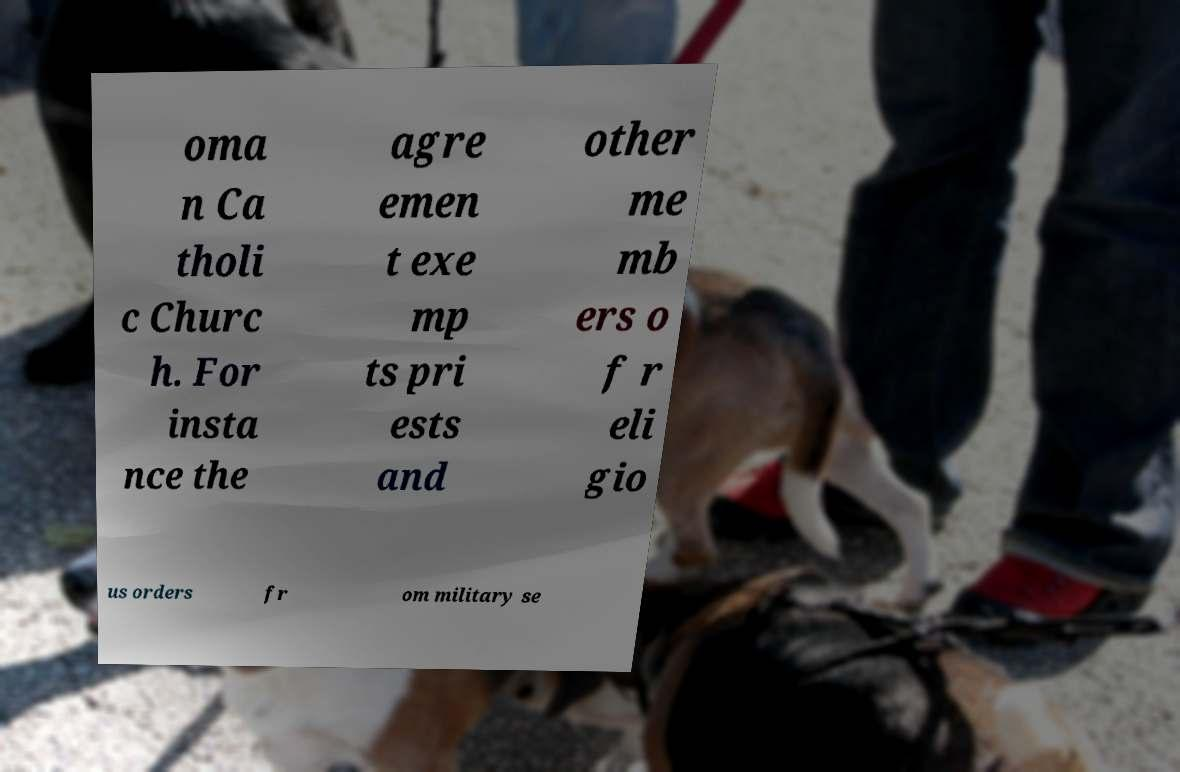Can you read and provide the text displayed in the image?This photo seems to have some interesting text. Can you extract and type it out for me? oma n Ca tholi c Churc h. For insta nce the agre emen t exe mp ts pri ests and other me mb ers o f r eli gio us orders fr om military se 